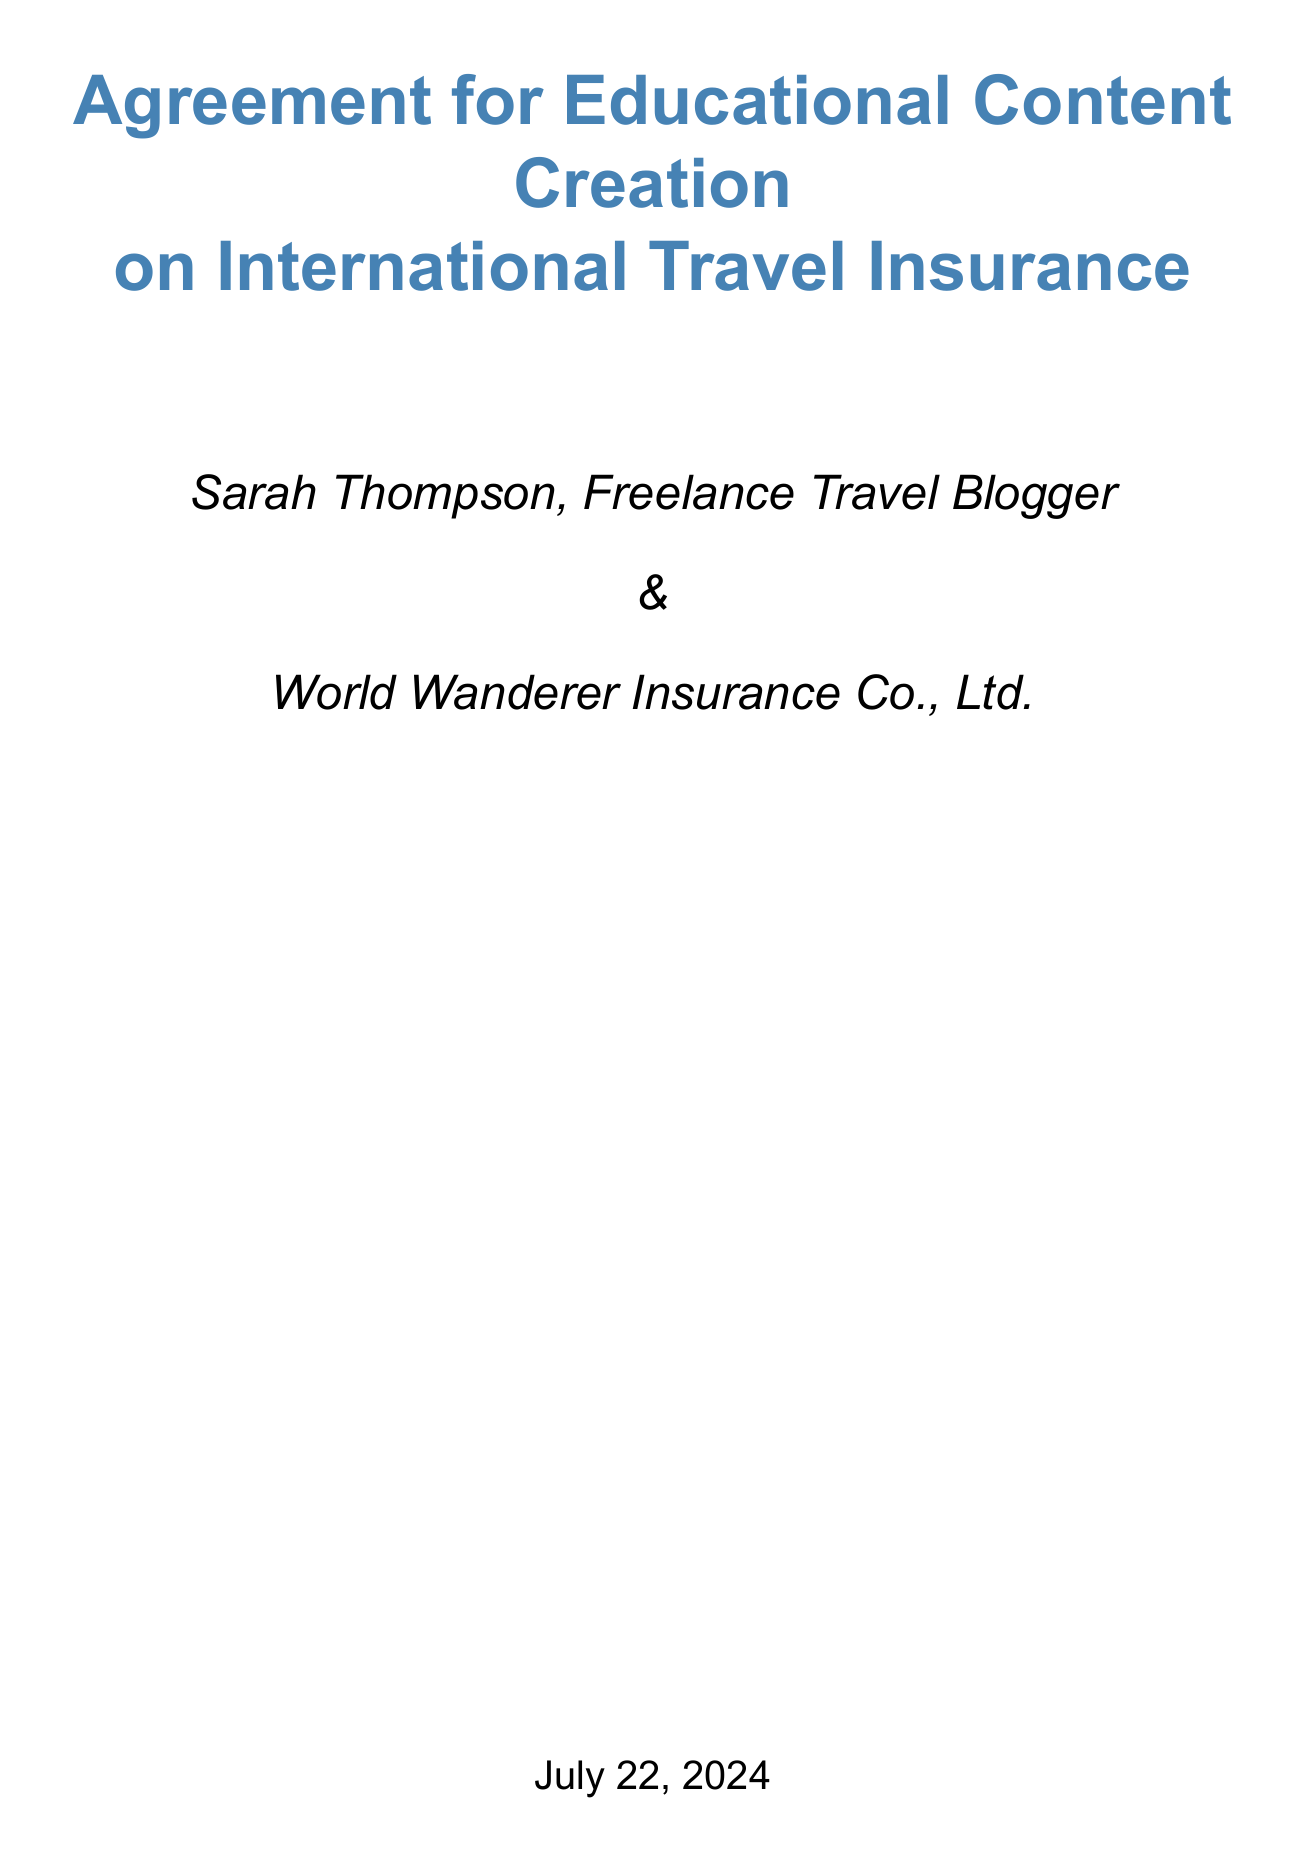What is the title of the contract? The title of the contract is stated at the beginning of the document.
Answer: Agreement for Educational Content Creation on International Travel Insurance Who is the content creator? The document identifies the content creator as a specific individual.
Answer: Sarah Thompson, Freelance Travel Blogger What is the total project value? The total project value is outlined in the compensation section of the document.
Answer: $6,000 How many infographics are to be delivered? The number of infographics is specified in the deliverables section.
Answer: 6 When does the project start? The start date is listed in the timeline section of the document.
Answer: July 1, 2023 What is the allowed number of revisions per content piece? The document specifies the number of revisions permitted in the revisions section.
Answer: Two rounds What percentage discount on insurance policies is offered? The document mentions the travel perks offered to the content creator.
Answer: 50% What is the compensation for one blog post? The compensation for each type of content is detailed in the compensation section.
Answer: $250 What is the primary target audience for the content? The target audience is described in the content guidelines section of the document.
Answer: Millennials and Gen Z travelers aged 25-40 